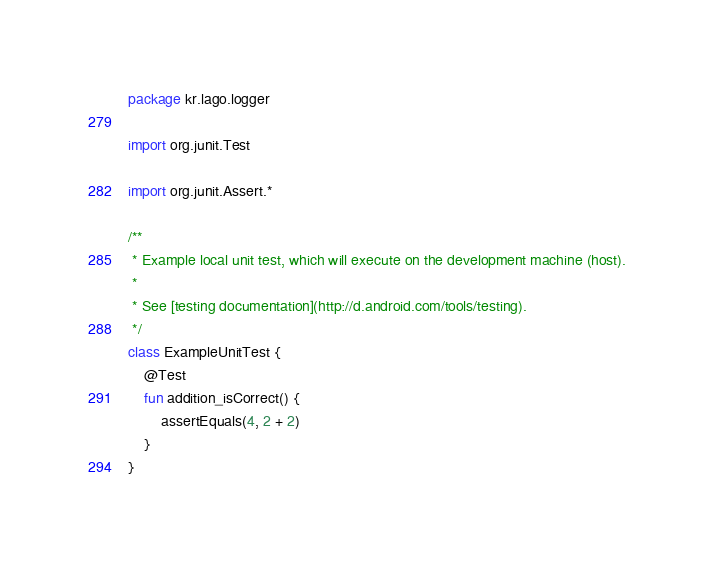Convert code to text. <code><loc_0><loc_0><loc_500><loc_500><_Kotlin_>package kr.lago.logger

import org.junit.Test

import org.junit.Assert.*

/**
 * Example local unit test, which will execute on the development machine (host).
 *
 * See [testing documentation](http://d.android.com/tools/testing).
 */
class ExampleUnitTest {
    @Test
    fun addition_isCorrect() {
        assertEquals(4, 2 + 2)
    }
}
</code> 